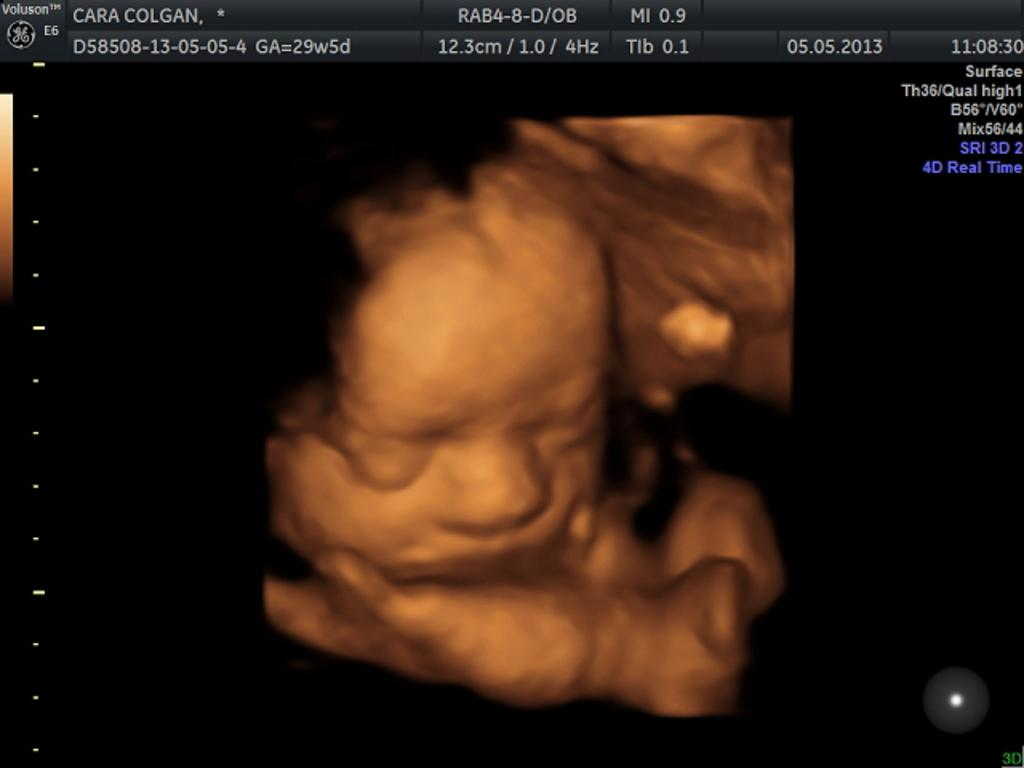What is the main feature of the image? There is a screen in the image. What can be seen on the screen? The screen contains text and an image of a baby. How many books are stacked on the drawer in the image? There is no mention of books or a drawer in the image; the image only features a screen with text and an image of a baby. 